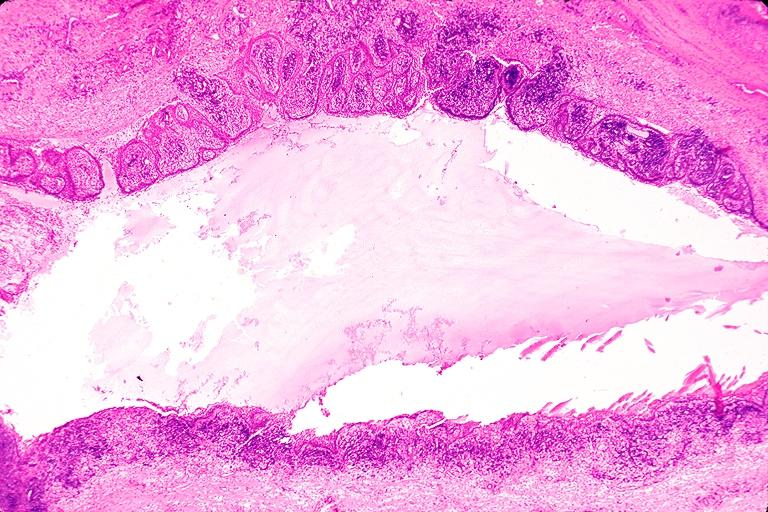s obvious metastatic lesion 44yobfadenocarcinoma of lung giant cell type present?
Answer the question using a single word or phrase. No 